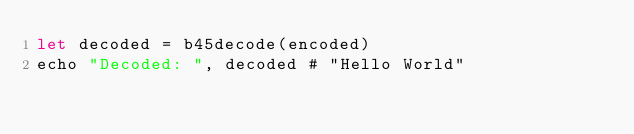Convert code to text. <code><loc_0><loc_0><loc_500><loc_500><_Nim_>let decoded = b45decode(encoded)
echo "Decoded: ", decoded # "Hello World"
</code> 